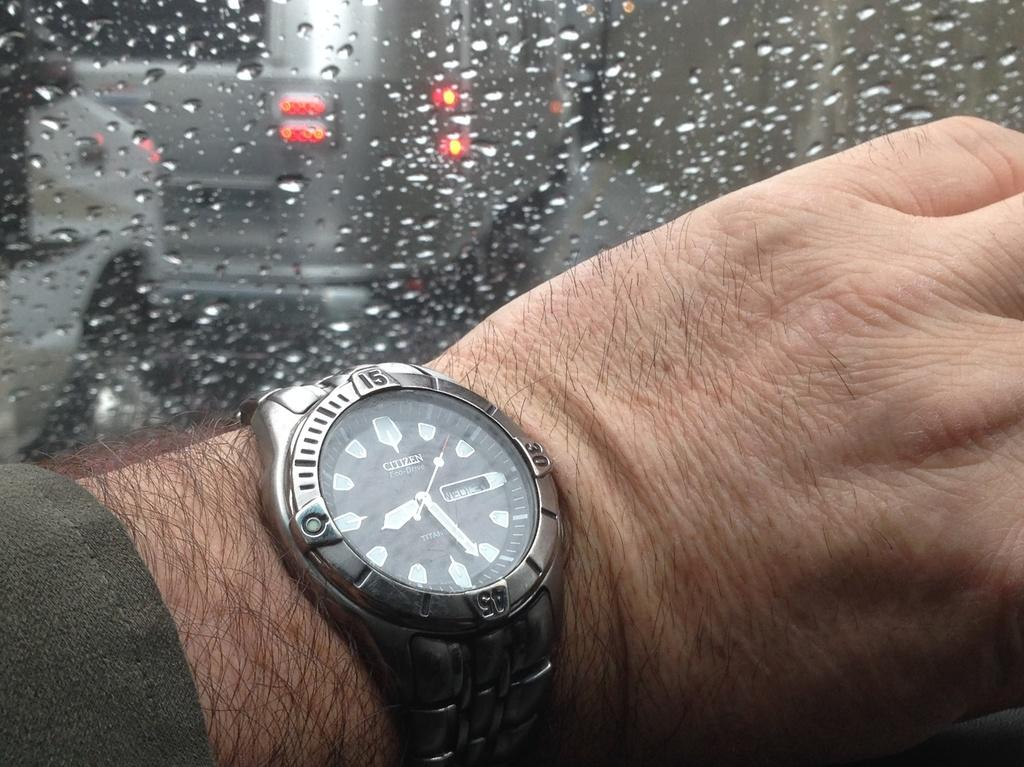What part of a man can be seen in the image? There is a man's hand in the image. What accessory is the man wearing on his hand? The man is wearing a watch. What object is present in the image that allows us to see outside? There is a glass in the image. What can be seen through the glass? A car is visible through the glass. What is the car doing in the image? The car is moving on the road. Can we determine the weather conditions from the image? It might be raining outside, as suggested by the presence of a car moving on the road. What process is the man using to generate a spark in the image? There is no indication of a process or spark in the image; it only shows a man's hand wearing a watch and a car moving on the road. 